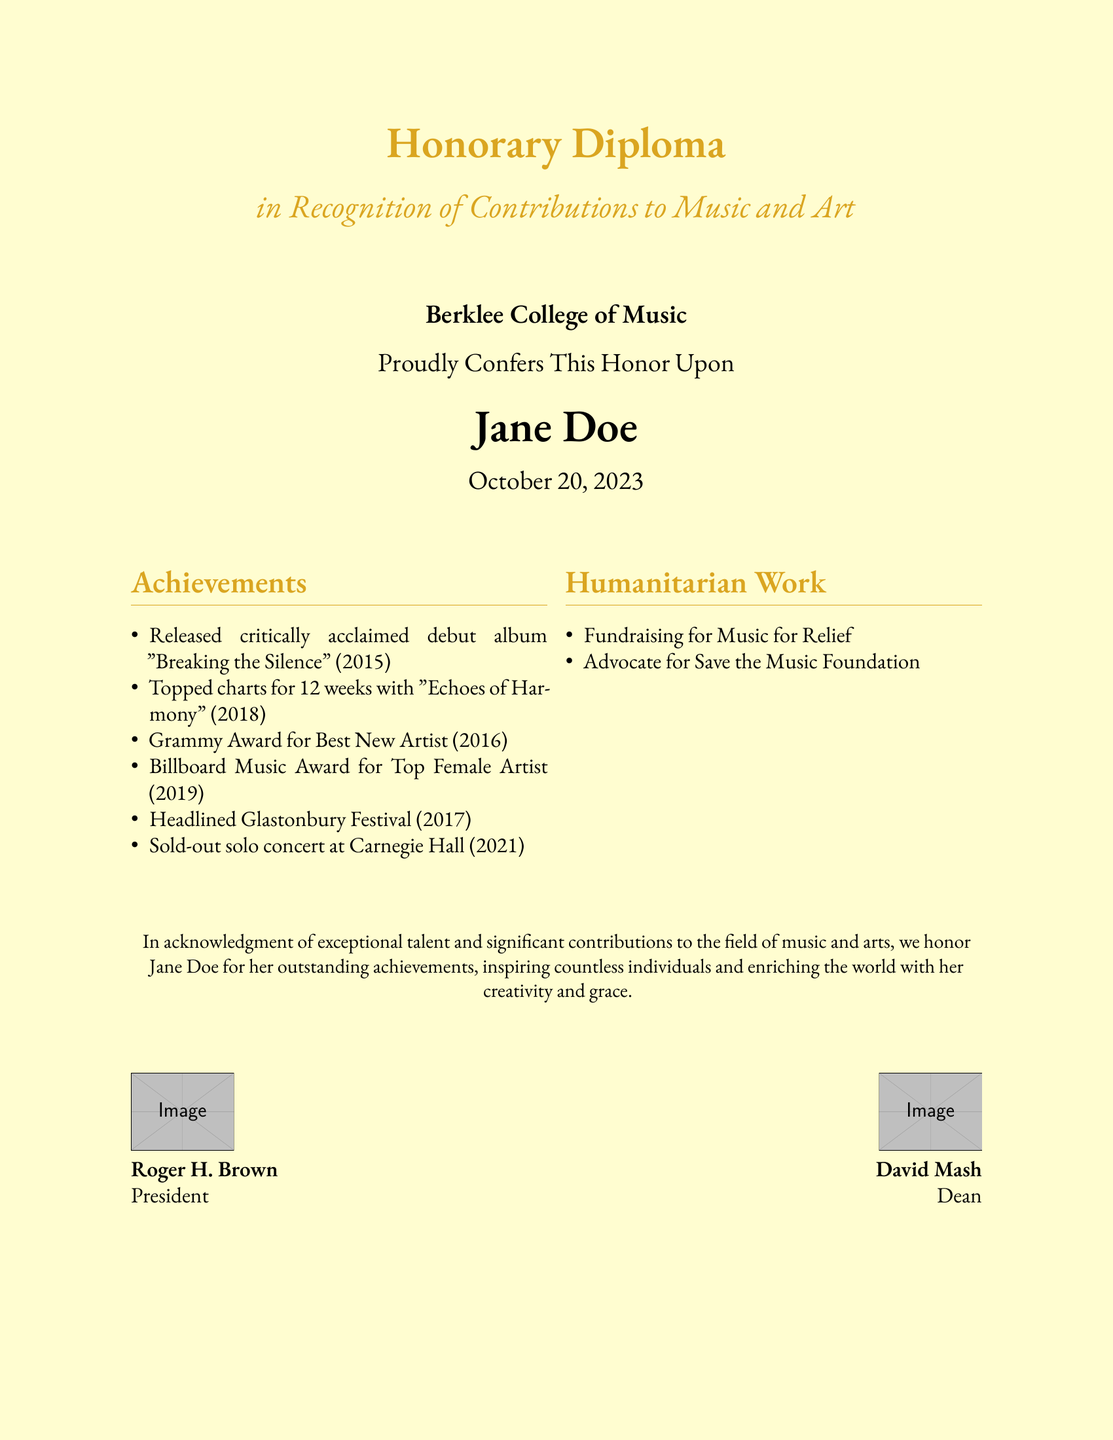what is the title of the diploma? The title is clearly stated at the top of the document as "Honorary Diploma".
Answer: Honorary Diploma who is the recipient of the diploma? The recipient's name is prominently displayed in the center of the document as "Jane Doe".
Answer: Jane Doe when was the diploma conferred? The date of conferment is listed as "October 20, 2023".
Answer: October 20, 2023 which college awarded the diploma? The college that conferred the diploma is identified as "Berklee College of Music".
Answer: Berklee College of Music how many weeks did "Echoes of Harmony" top the charts? The document states that "Echoes of Harmony" topped the charts for "12 weeks".
Answer: 12 weeks what was the debut album released by Jane Doe? The debut album mentioned is "Breaking the Silence".
Answer: Breaking the Silence which prestigious festival did Jane Doe headline? The festival is referred to as "Glastonbury Festival".
Answer: Glastonbury Festival how many awards did Jane Doe win in 2016? She won "one award", which is for Best New Artist.
Answer: one who is the President of Berklee College of Music? The document lists "Roger H. Brown" as the President.
Answer: Roger H. Brown what is one of the humanitarian organizations Jane Doe is associated with? The document mentions her as an advocate for the "Save the Music Foundation".
Answer: Save the Music Foundation 